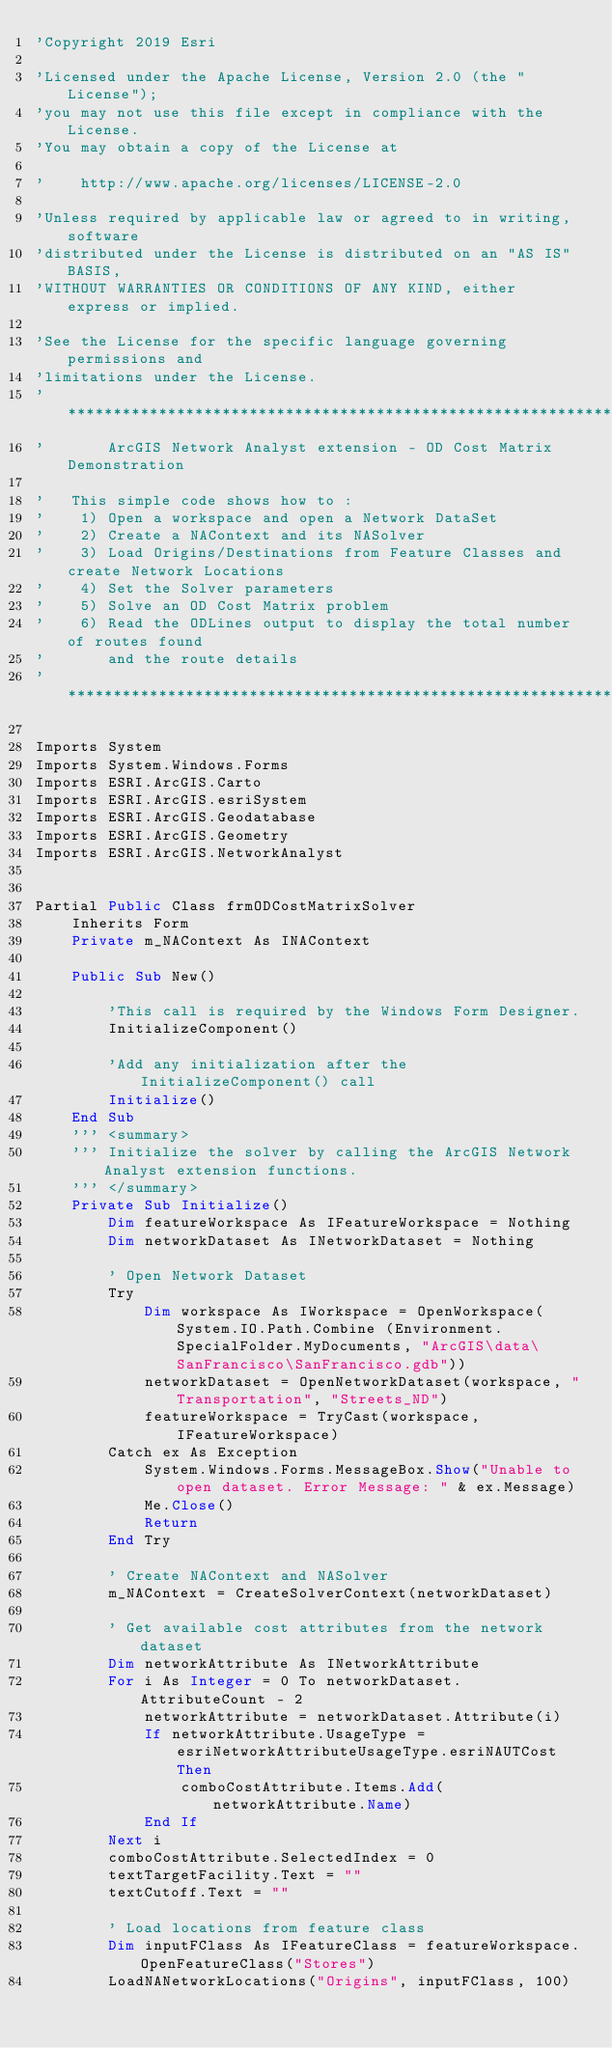<code> <loc_0><loc_0><loc_500><loc_500><_VisualBasic_>'Copyright 2019 Esri

'Licensed under the Apache License, Version 2.0 (the "License");
'you may not use this file except in compliance with the License.
'You may obtain a copy of the License at

'    http://www.apache.org/licenses/LICENSE-2.0

'Unless required by applicable law or agreed to in writing, software
'distributed under the License is distributed on an "AS IS" BASIS,
'WITHOUT WARRANTIES OR CONDITIONS OF ANY KIND, either express or implied.

'See the License for the specific language governing permissions and
'limitations under the License.
'*************************************************************************************
'       ArcGIS Network Analyst extension - OD Cost Matrix Demonstration

'   This simple code shows how to :
'    1) Open a workspace and open a Network DataSet
'    2) Create a NAContext and its NASolver
'    3) Load Origins/Destinations from Feature Classes and create Network Locations
'    4) Set the Solver parameters
'    5) Solve an OD Cost Matrix problem
'    6) Read the ODLines output to display the total number of routes found 
'       and the route details
'************************************************************************************

Imports System
Imports System.Windows.Forms
Imports ESRI.ArcGIS.Carto
Imports ESRI.ArcGIS.esriSystem
Imports ESRI.ArcGIS.Geodatabase
Imports ESRI.ArcGIS.Geometry
Imports ESRI.ArcGIS.NetworkAnalyst


Partial Public Class frmODCostMatrixSolver
	Inherits Form
	Private m_NAContext As INAContext

	Public Sub New()

		'This call is required by the Windows Form Designer.
		InitializeComponent()

		'Add any initialization after the InitializeComponent() call
		Initialize()
	End Sub
	''' <summary>
    ''' Initialize the solver by calling the ArcGIS Network Analyst extension functions.
	''' </summary>
	Private Sub Initialize()
		Dim featureWorkspace As IFeatureWorkspace = Nothing
		Dim networkDataset As INetworkDataset = Nothing

		' Open Network Dataset
		Try
			Dim workspace As IWorkspace = OpenWorkspace(System.IO.Path.Combine (Environment.SpecialFolder.MyDocuments, "ArcGIS\data\SanFrancisco\SanFrancisco.gdb"))
			networkDataset = OpenNetworkDataset(workspace, "Transportation", "Streets_ND")
			featureWorkspace = TryCast(workspace, IFeatureWorkspace)
		Catch ex As Exception
			System.Windows.Forms.MessageBox.Show("Unable to open dataset. Error Message: " & ex.Message)
			Me.Close()
			Return
		End Try

		' Create NAContext and NASolver
		m_NAContext = CreateSolverContext(networkDataset)

		' Get available cost attributes from the network dataset
		Dim networkAttribute As INetworkAttribute
		For i As Integer = 0 To networkDataset.AttributeCount - 2
			networkAttribute = networkDataset.Attribute(i)
			If networkAttribute.UsageType = esriNetworkAttributeUsageType.esriNAUTCost Then
				comboCostAttribute.Items.Add(networkAttribute.Name)
			End If
		Next i
		comboCostAttribute.SelectedIndex = 0
		textTargetFacility.Text = ""
		textCutoff.Text = ""

		' Load locations from feature class
		Dim inputFClass As IFeatureClass = featureWorkspace.OpenFeatureClass("Stores")
		LoadNANetworkLocations("Origins", inputFClass, 100)
</code> 